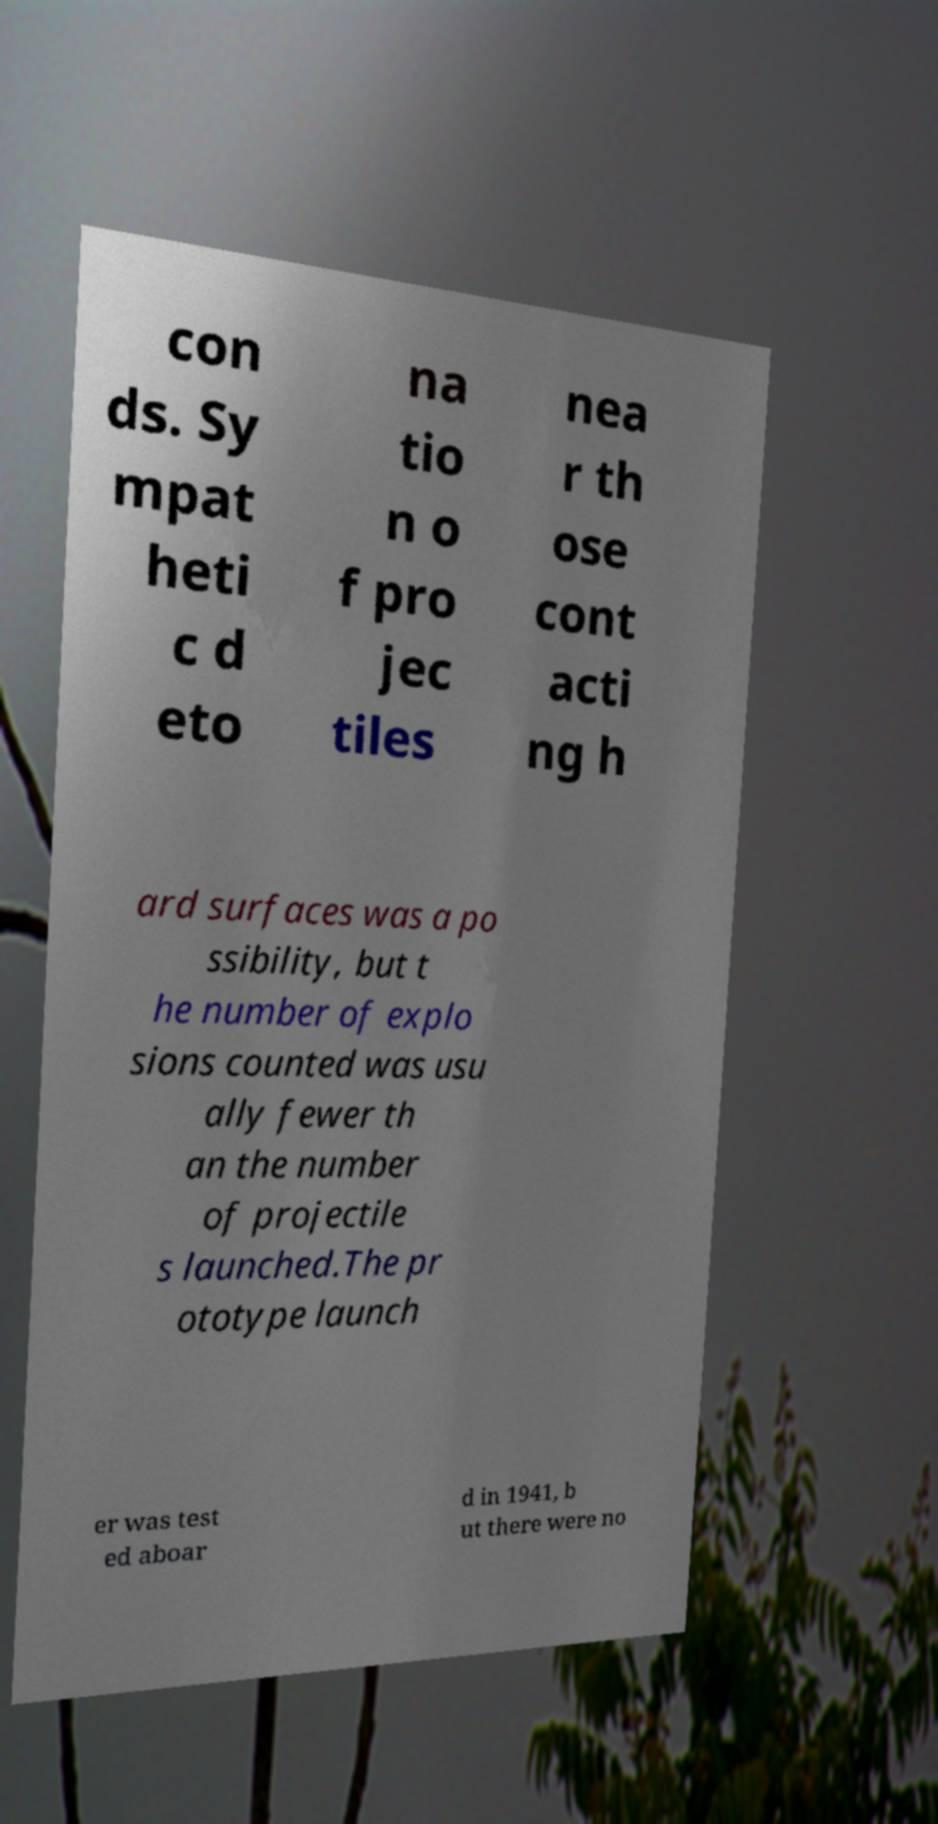There's text embedded in this image that I need extracted. Can you transcribe it verbatim? con ds. Sy mpat heti c d eto na tio n o f pro jec tiles nea r th ose cont acti ng h ard surfaces was a po ssibility, but t he number of explo sions counted was usu ally fewer th an the number of projectile s launched.The pr ototype launch er was test ed aboar d in 1941, b ut there were no 